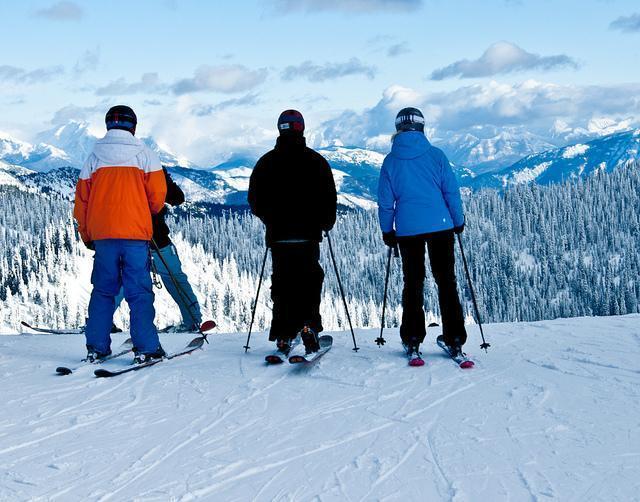How many people can you see?
Give a very brief answer. 4. 